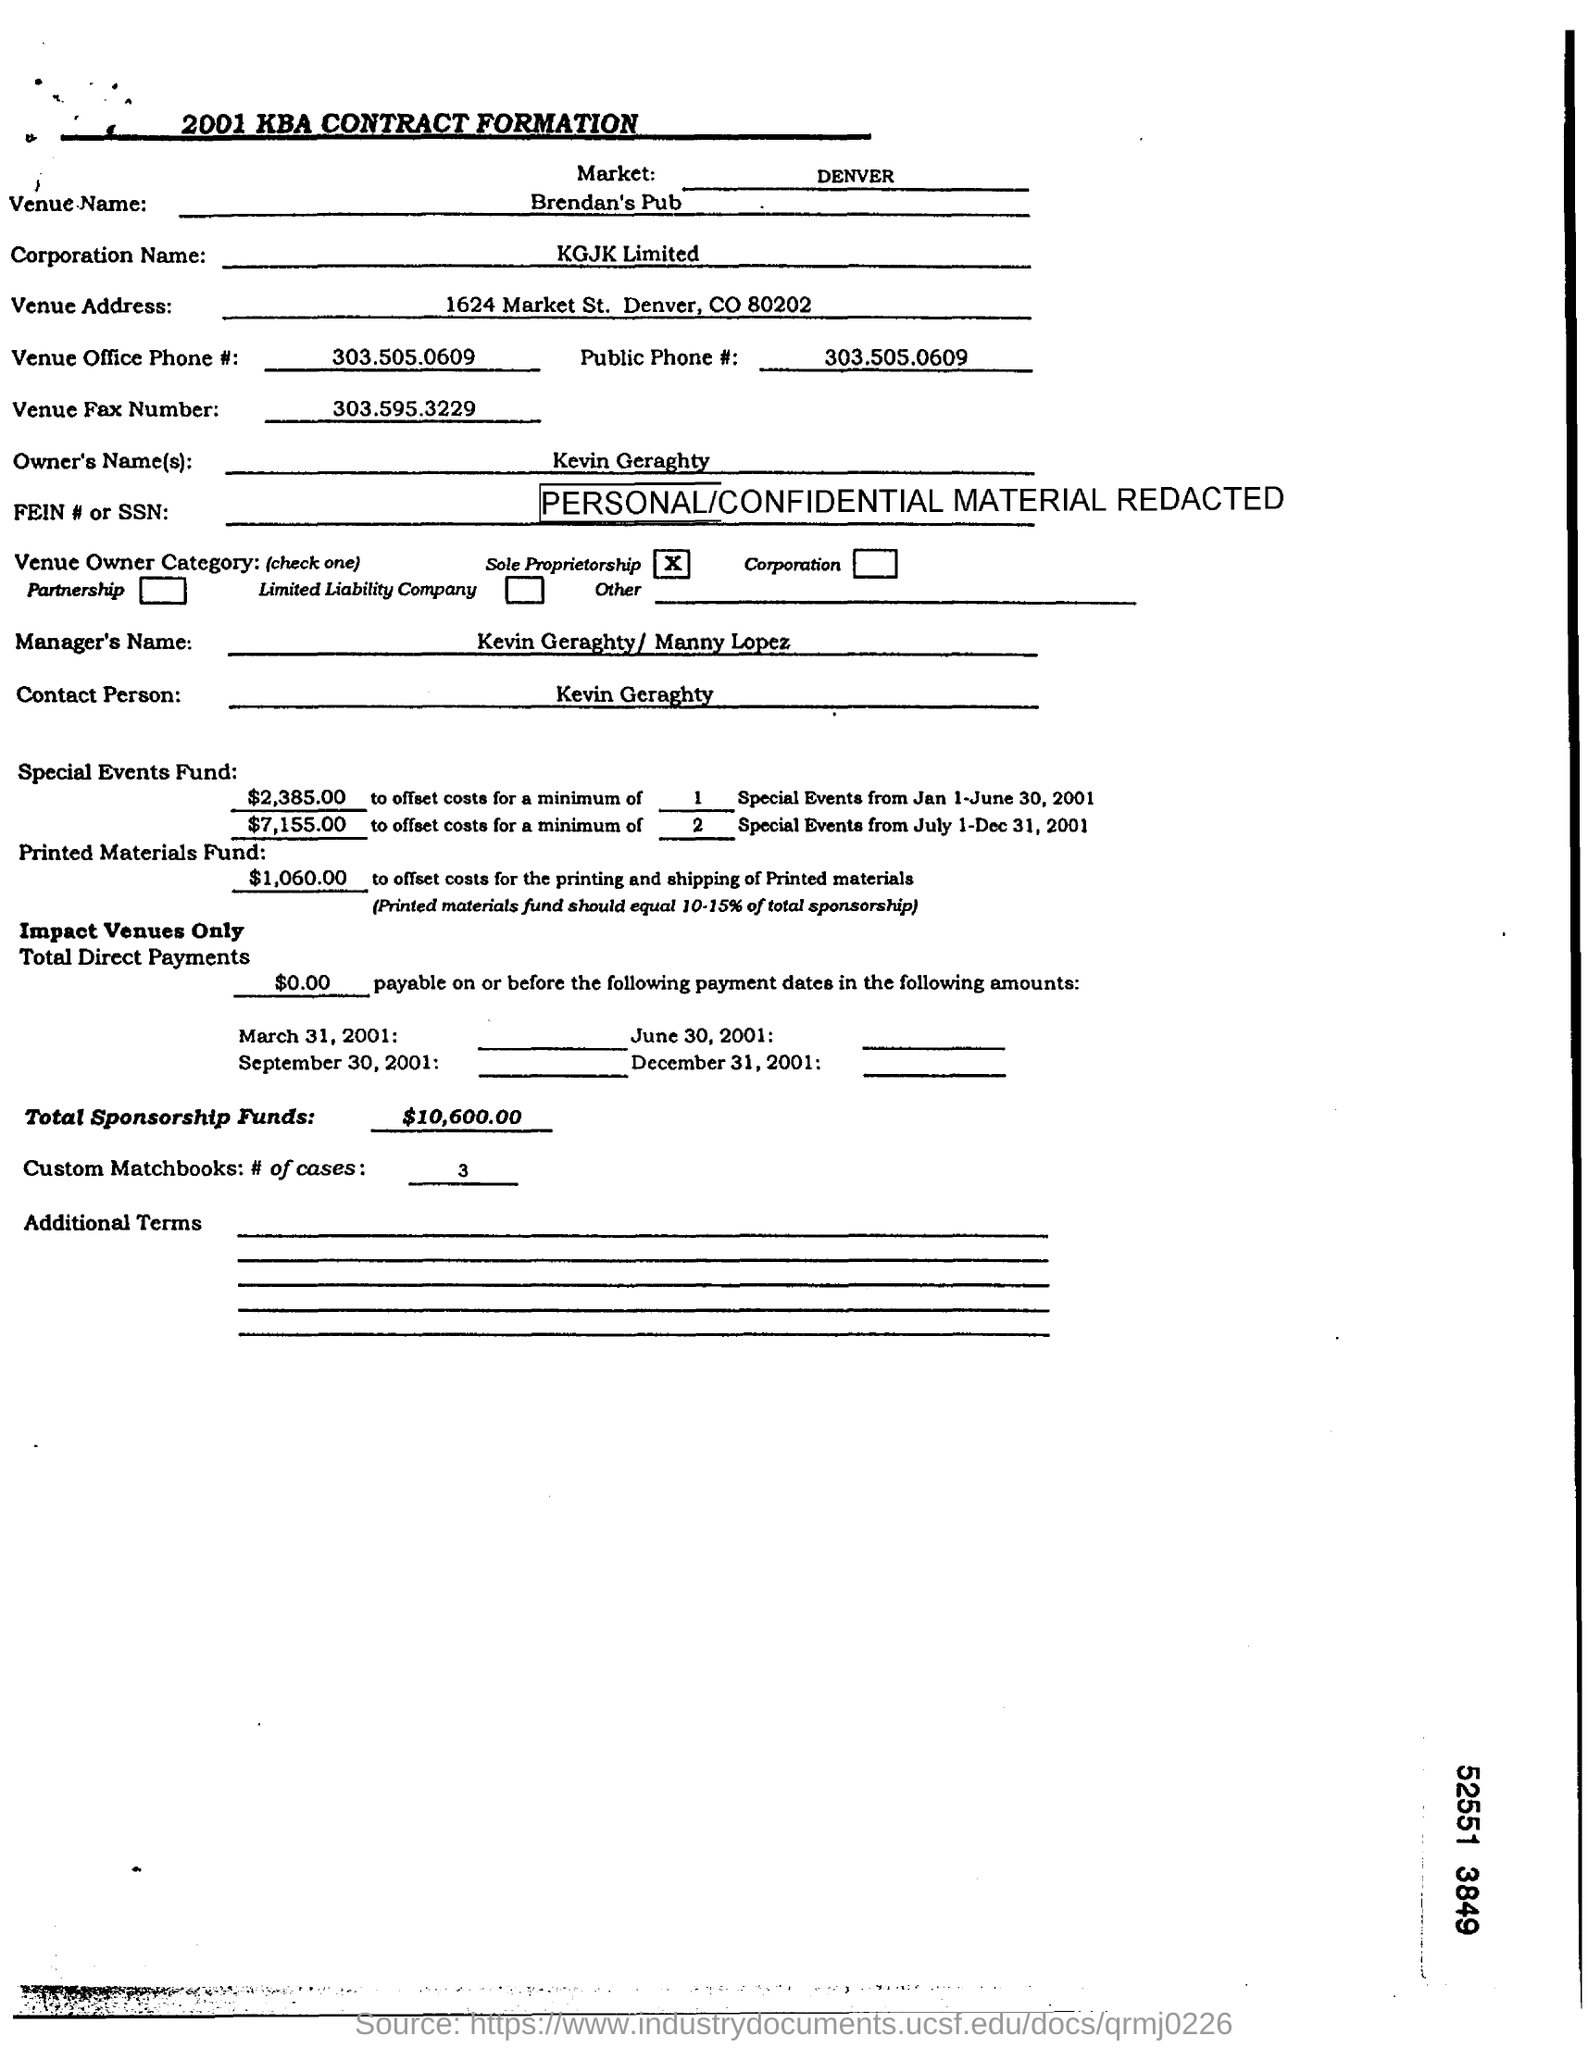Where is the venue?
Offer a very short reply. Brendan's Pub. What is the name of the corporation?
Ensure brevity in your answer.  KGJK LImited. What is the venue office phone number?
Your answer should be compact. 303.505.0609. What is the venue fax number?
Ensure brevity in your answer.  303.595.3229. Who is the owner?
Provide a succinct answer. Kevin Geraghty. Who is the manager?
Keep it short and to the point. Kevin Geraghty / Manny Lopez. Who is the contact person?
Your answer should be very brief. Kevin Geraghty. Where is the market?
Keep it short and to the point. DENVER. 